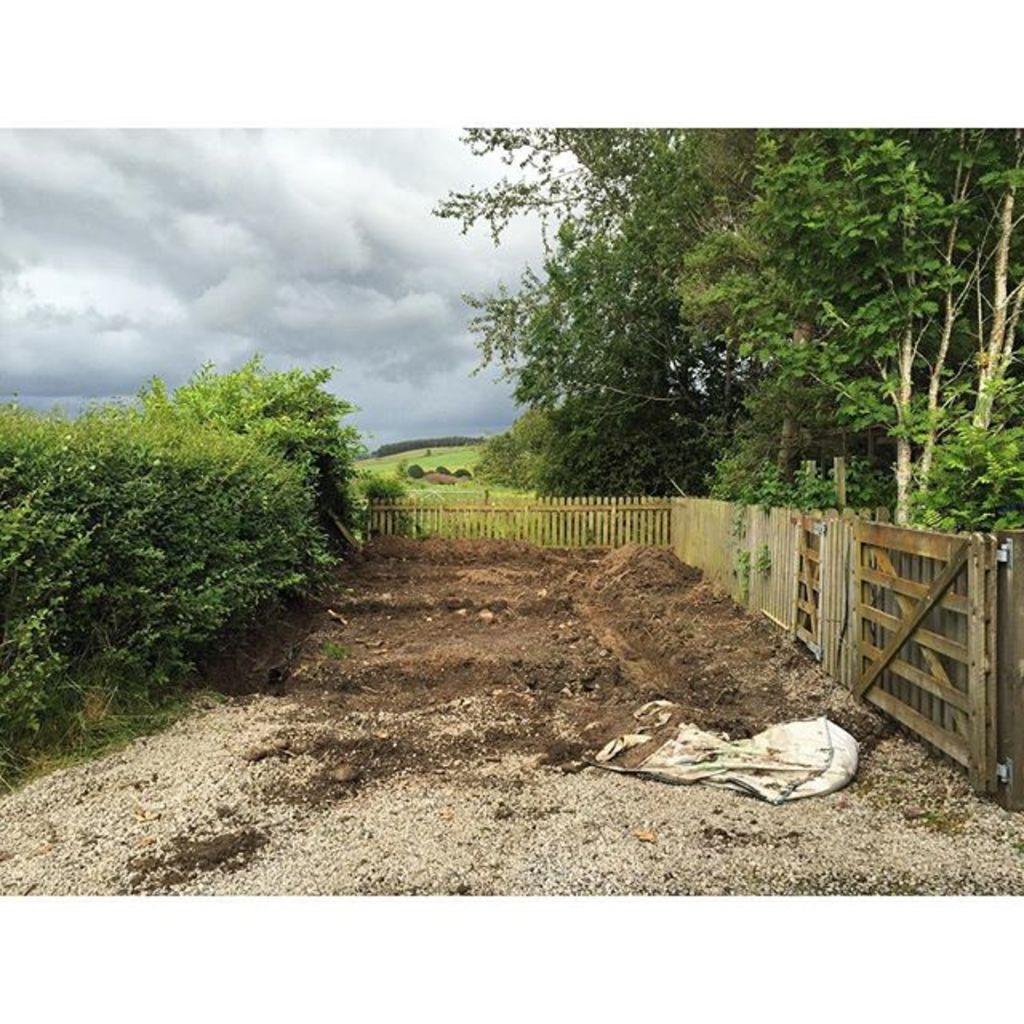In one or two sentences, can you explain what this image depicts? On the left side, there are plants on the ground. On the right side, there is a wooden fence. Beside this fence, there is a white color bag on the dry land. In the background, there are trees and grass on the ground and there are clouds in the sky. 